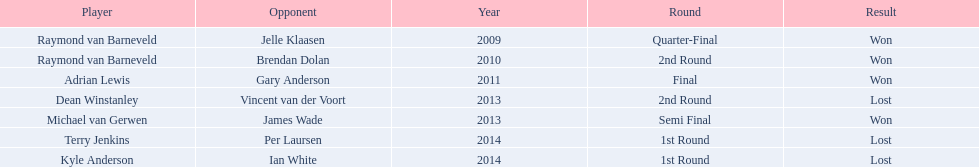Who are all the players? Raymond van Barneveld, Raymond van Barneveld, Adrian Lewis, Dean Winstanley, Michael van Gerwen, Terry Jenkins, Kyle Anderson. When did they play? 2009, 2010, 2011, 2013, 2013, 2014, 2014. And which player played in 2011? Adrian Lewis. 